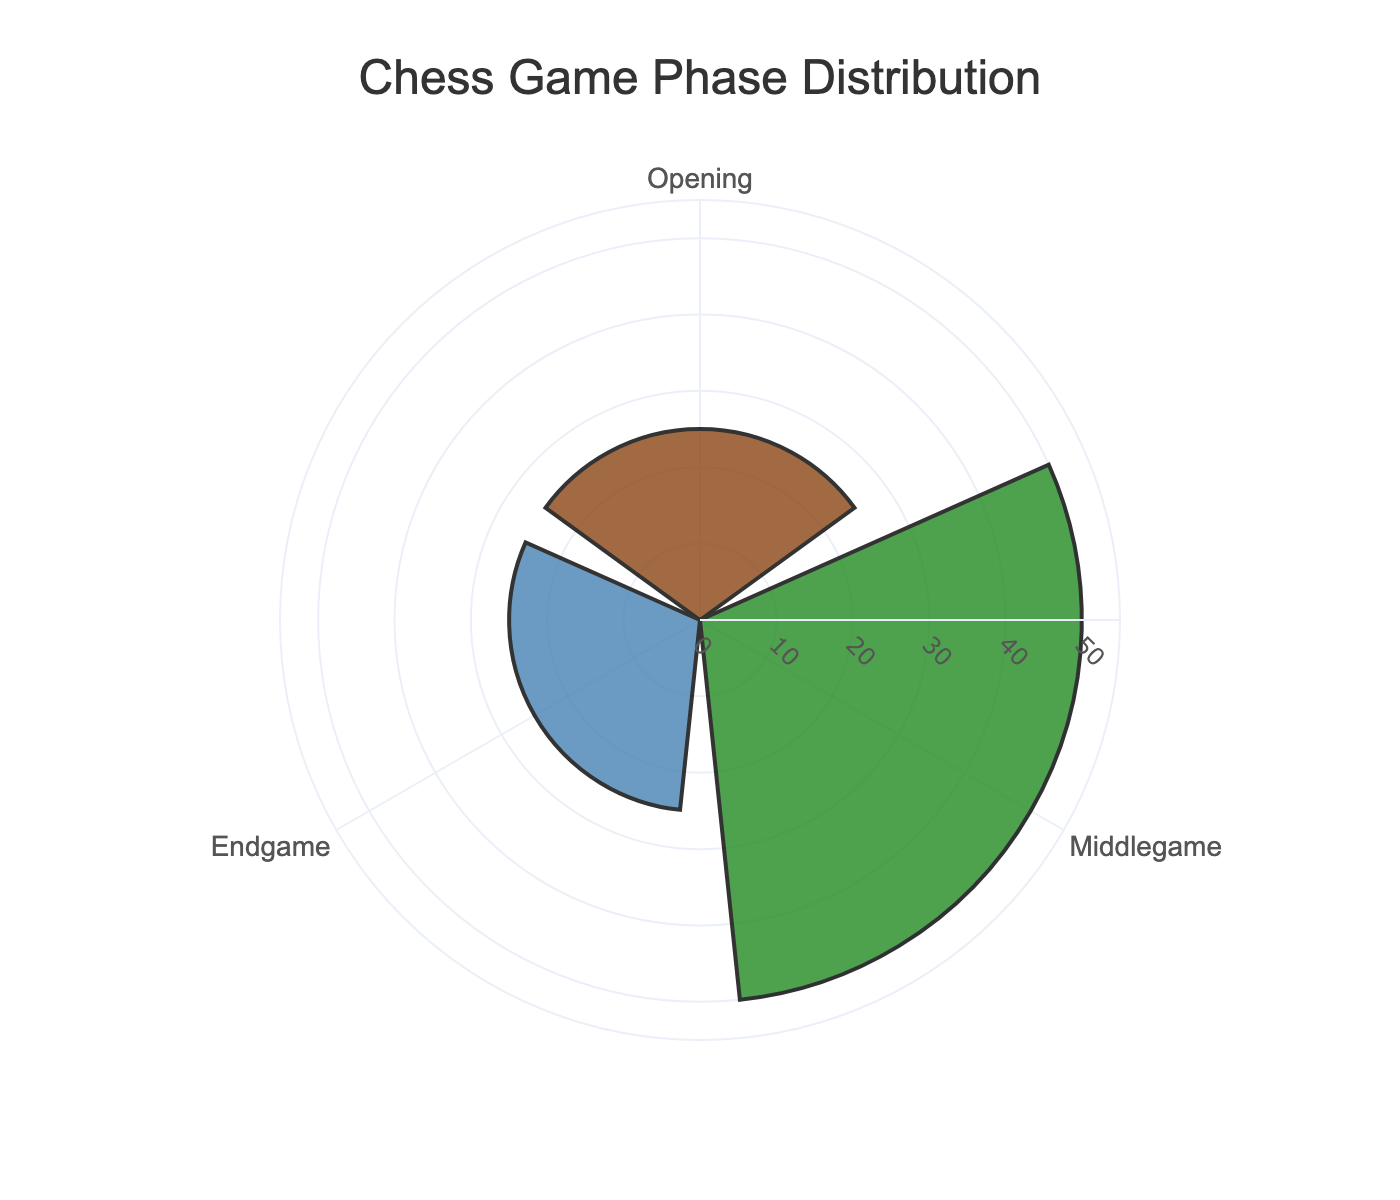what is the title of the figure? The title is usually located at the top of the figure and provides a brief description of what the figure is about. In this case, the title is "Chess Game Phase Distribution."
Answer: Chess Game Phase Distribution what phase spends the most time in a chess game? The proportions represented in the figure indicate the amount of time spent on each phase. The phase with the largest section or value represents the most time spent. In this figure, the Middlegame has the highest proportion at 50%.
Answer: Middlegame what is the difference in time spent between the Middlegame and the Opening? To find the difference, subtract the proportion of the Opening from that of the Middlegame. The Middlegame proportion is 50%, and the Opening proportion is 25%, so 50% - 25% = 25%.
Answer: 25% are any phases equally represented in time spent during a chess game? By comparing the proportions, we can see if any phases have equal values. In this case, both the Opening and Endgame have the same proportion of 25%.
Answer: Yes if you add the proportion of time spent on the Opening and Endgame phases, what value do you get? Sum the proportions of the Opening and Endgame phases. Both have a value of 25%, so 25% + 25% = 50%.
Answer: 50% what does the color brown represent in the figure? In the rose chart, colors are used to distinguish between different groups. Based on the provided code, the color brown represents the Opening phase.
Answer: Opening which phase has both the smallest proportion and the smallest section in the rose chart? Since the sections and proportions are directly correlated, the phases with the smallest proportions will have the smallest sections as well. Both the Opening and Endgame have the smallest proportion of 25%.
Answer: Opening and Endgame which direction is used for labeling the angular axis in the rose chart? The code specifies that the angular axis direction is clockwise. This helps in understanding how the phase labels are positioned.
Answer: Clockwise 